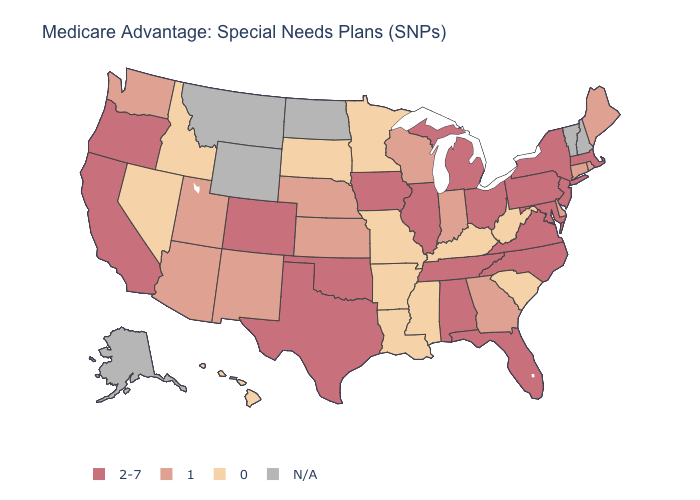How many symbols are there in the legend?
Concise answer only. 4. What is the lowest value in the USA?
Write a very short answer. 0. How many symbols are there in the legend?
Keep it brief. 4. Does Louisiana have the lowest value in the USA?
Keep it brief. Yes. Name the states that have a value in the range 2-7?
Quick response, please. Alabama, California, Colorado, Florida, Iowa, Illinois, Massachusetts, Maryland, Michigan, North Carolina, New Jersey, New York, Ohio, Oklahoma, Oregon, Pennsylvania, Tennessee, Texas, Virginia. Name the states that have a value in the range 0?
Give a very brief answer. Arkansas, Hawaii, Idaho, Kentucky, Louisiana, Minnesota, Missouri, Mississippi, Nevada, South Carolina, South Dakota, West Virginia. What is the value of Connecticut?
Give a very brief answer. 1. Does Pennsylvania have the lowest value in the USA?
Write a very short answer. No. What is the value of Florida?
Give a very brief answer. 2-7. Does Pennsylvania have the highest value in the USA?
Be succinct. Yes. What is the highest value in states that border Indiana?
Short answer required. 2-7. Is the legend a continuous bar?
Concise answer only. No. What is the value of Mississippi?
Be succinct. 0. What is the highest value in the USA?
Short answer required. 2-7. 